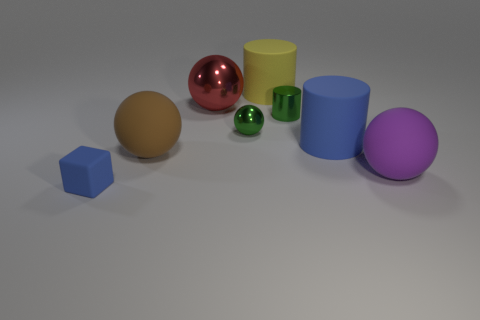Subtract 1 balls. How many balls are left? 3 Add 2 yellow matte cylinders. How many objects exist? 10 Subtract all cylinders. How many objects are left? 5 Subtract all tiny green metal cylinders. Subtract all shiny balls. How many objects are left? 5 Add 4 tiny cylinders. How many tiny cylinders are left? 5 Add 2 cyan shiny objects. How many cyan shiny objects exist? 2 Subtract 0 blue balls. How many objects are left? 8 